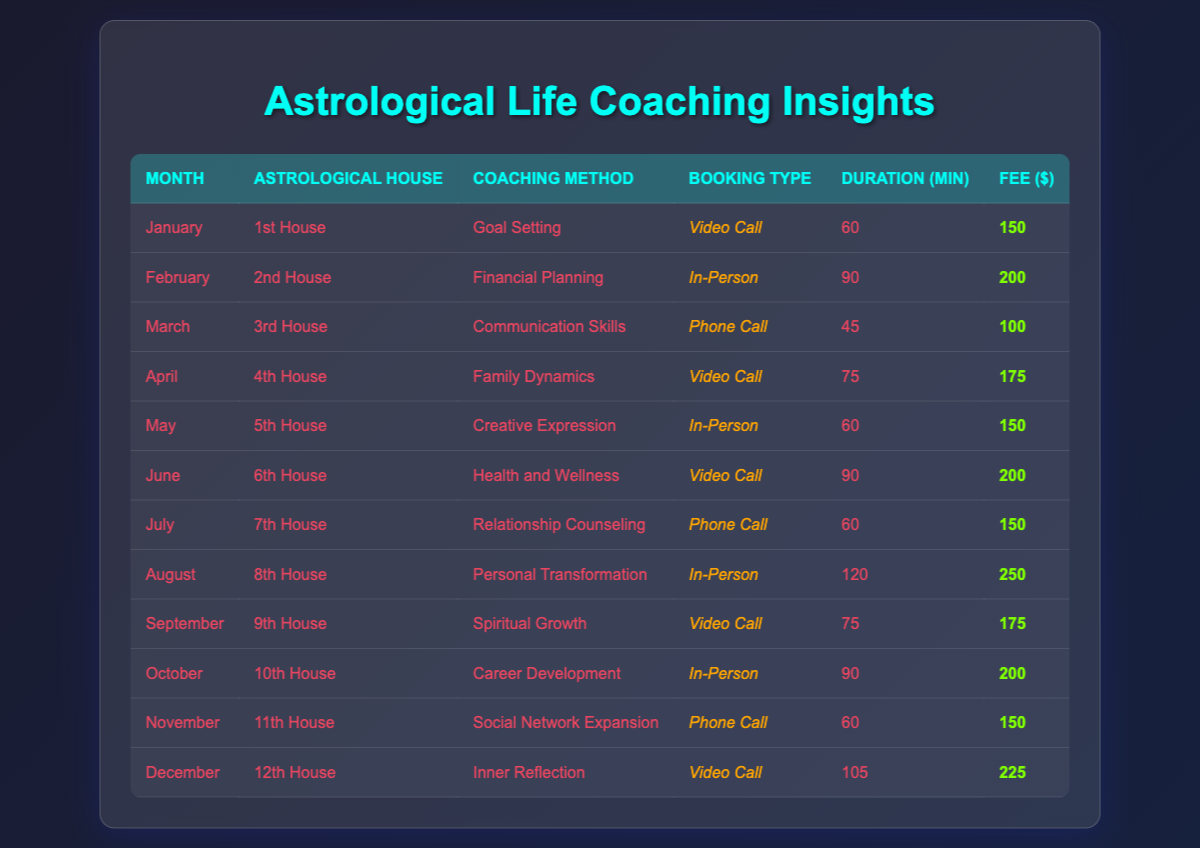What is the total fee collected from client bookings in August? In August, there is one booking with a fee of 250. Thus, the total fee collected for client bookings in August is 250.
Answer: 250 Which coaching method was preferred by clients in the 12th House? In the 12th House, the coaching method listed is "Inner Reflection." Therefore, the preferred coaching method for the clients in this house is Inner Reflection.
Answer: Inner Reflection What is the average session duration for all video call bookings? The sessions are: January (60), April (75), June (90), September (75), December (105). The total duration is 60 + 75 + 90 + 75 + 105 = 405 minutes. Dividing by 5 gives an average of 405 / 5 = 81.
Answer: 81 How many clients booked in-person sessions in 2023? The months with in-person bookings are February, May, August, and October, totaling 4 clients who booked in-person sessions.
Answer: 4 Was there any booking for "Relationship Counseling" method in the 10th House? The 10th House has the coaching method "Career Development," not "Relationship Counseling." Thus, there was no booking for Relationship Counseling in the 10th House.
Answer: No What is the highest fee charged and during which month did it occur? The highest fee is 250, which corresponds to the booking in August.
Answer: 250 (August) What are the coaching methods used for the 5th and 9th House combined? The 5th House method is "Creative Expression," and the 9th House method is "Spiritual Growth." Therefore, the coaching methods combined for the 5th and 9th House are Creative Expression and Spiritual Growth.
Answer: Creative Expression, Spiritual Growth In which month did the least session duration occur, and how long was it? The shortest session duration is 45 minutes, occurring in March.
Answer: March, 45 How many months had a fee greater than 150 dollars? The months with fees greater than 150 are February (200), June (200), August (250), October (200), and December (225), totaling 5 months.
Answer: 5 Was "Goal Setting" the only coaching method offered in January? According to the data, January has only one entry with the coaching method "Goal Setting." Thus, it is the only method offered in that month.
Answer: Yes 